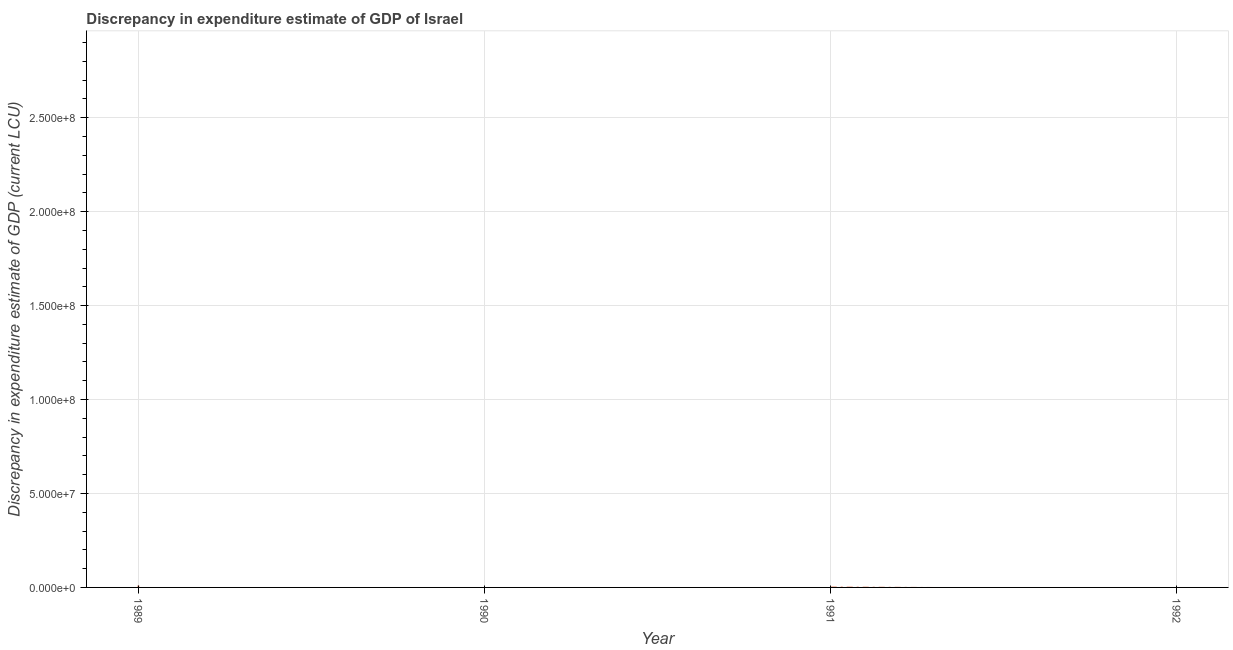Across all years, what is the maximum discrepancy in expenditure estimate of gdp?
Ensure brevity in your answer.  1.00e+06. In which year was the discrepancy in expenditure estimate of gdp maximum?
Offer a very short reply. 1989. What is the sum of the discrepancy in expenditure estimate of gdp?
Your answer should be compact. 1.00e+06. What is the difference between the discrepancy in expenditure estimate of gdp in 1989 and 1991?
Your answer should be very brief. 9.96e+05. What is the average discrepancy in expenditure estimate of gdp per year?
Keep it short and to the point. 2.51e+05. What is the median discrepancy in expenditure estimate of gdp?
Ensure brevity in your answer.  2050. In how many years, is the discrepancy in expenditure estimate of gdp greater than 230000000 LCU?
Your answer should be very brief. 0. What is the ratio of the discrepancy in expenditure estimate of gdp in 1989 to that in 1991?
Give a very brief answer. 244. Is the sum of the discrepancy in expenditure estimate of gdp in 1989 and 1991 greater than the maximum discrepancy in expenditure estimate of gdp across all years?
Give a very brief answer. Yes. What is the difference between the highest and the lowest discrepancy in expenditure estimate of gdp?
Provide a succinct answer. 1.00e+06. In how many years, is the discrepancy in expenditure estimate of gdp greater than the average discrepancy in expenditure estimate of gdp taken over all years?
Ensure brevity in your answer.  1. How many lines are there?
Keep it short and to the point. 1. What is the difference between two consecutive major ticks on the Y-axis?
Provide a short and direct response. 5.00e+07. Does the graph contain grids?
Your answer should be very brief. Yes. What is the title of the graph?
Your response must be concise. Discrepancy in expenditure estimate of GDP of Israel. What is the label or title of the Y-axis?
Offer a terse response. Discrepancy in expenditure estimate of GDP (current LCU). What is the Discrepancy in expenditure estimate of GDP (current LCU) in 1989?
Give a very brief answer. 1.00e+06. What is the Discrepancy in expenditure estimate of GDP (current LCU) of 1991?
Your answer should be very brief. 4100. What is the difference between the Discrepancy in expenditure estimate of GDP (current LCU) in 1989 and 1991?
Your answer should be compact. 9.96e+05. What is the ratio of the Discrepancy in expenditure estimate of GDP (current LCU) in 1989 to that in 1991?
Ensure brevity in your answer.  244. 